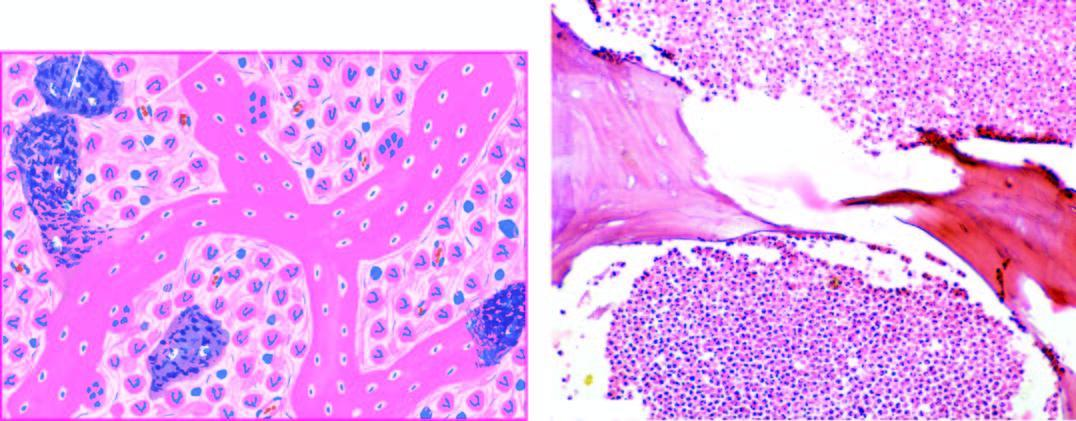does the basement membrane show necrotic bone and extensive purulent inflammatory exudate?
Answer the question using a single word or phrase. No 